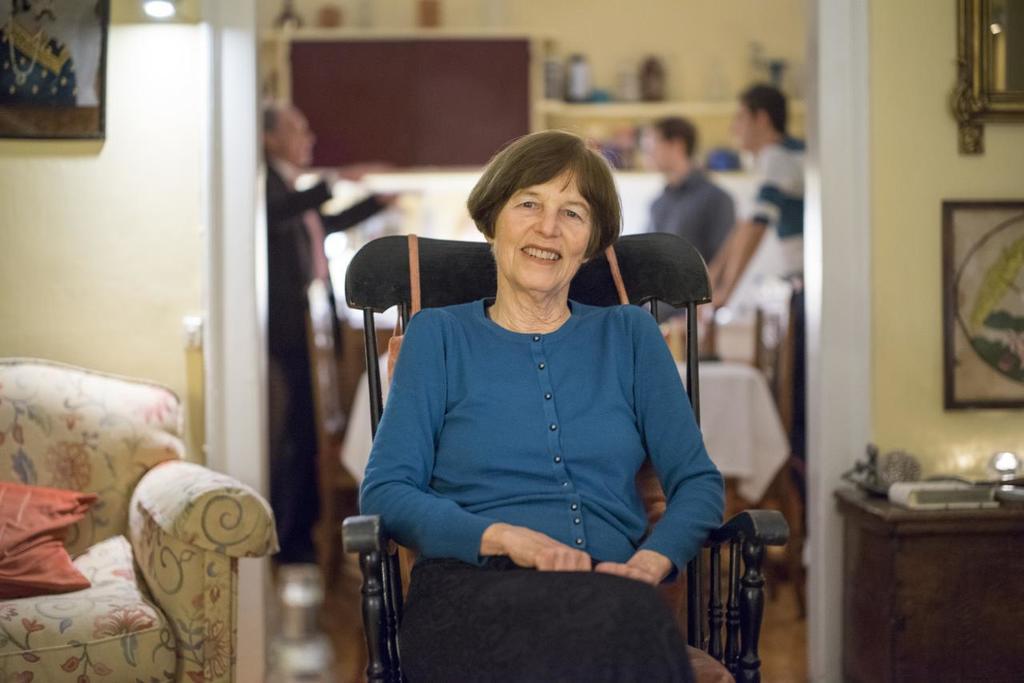Describe this image in one or two sentences. In the center we can see one woman she is sitting on chair and she is smiling. And on the left side we can see the sofa. Coming to the background we can see the photo frame,wall and few persons were standing. 